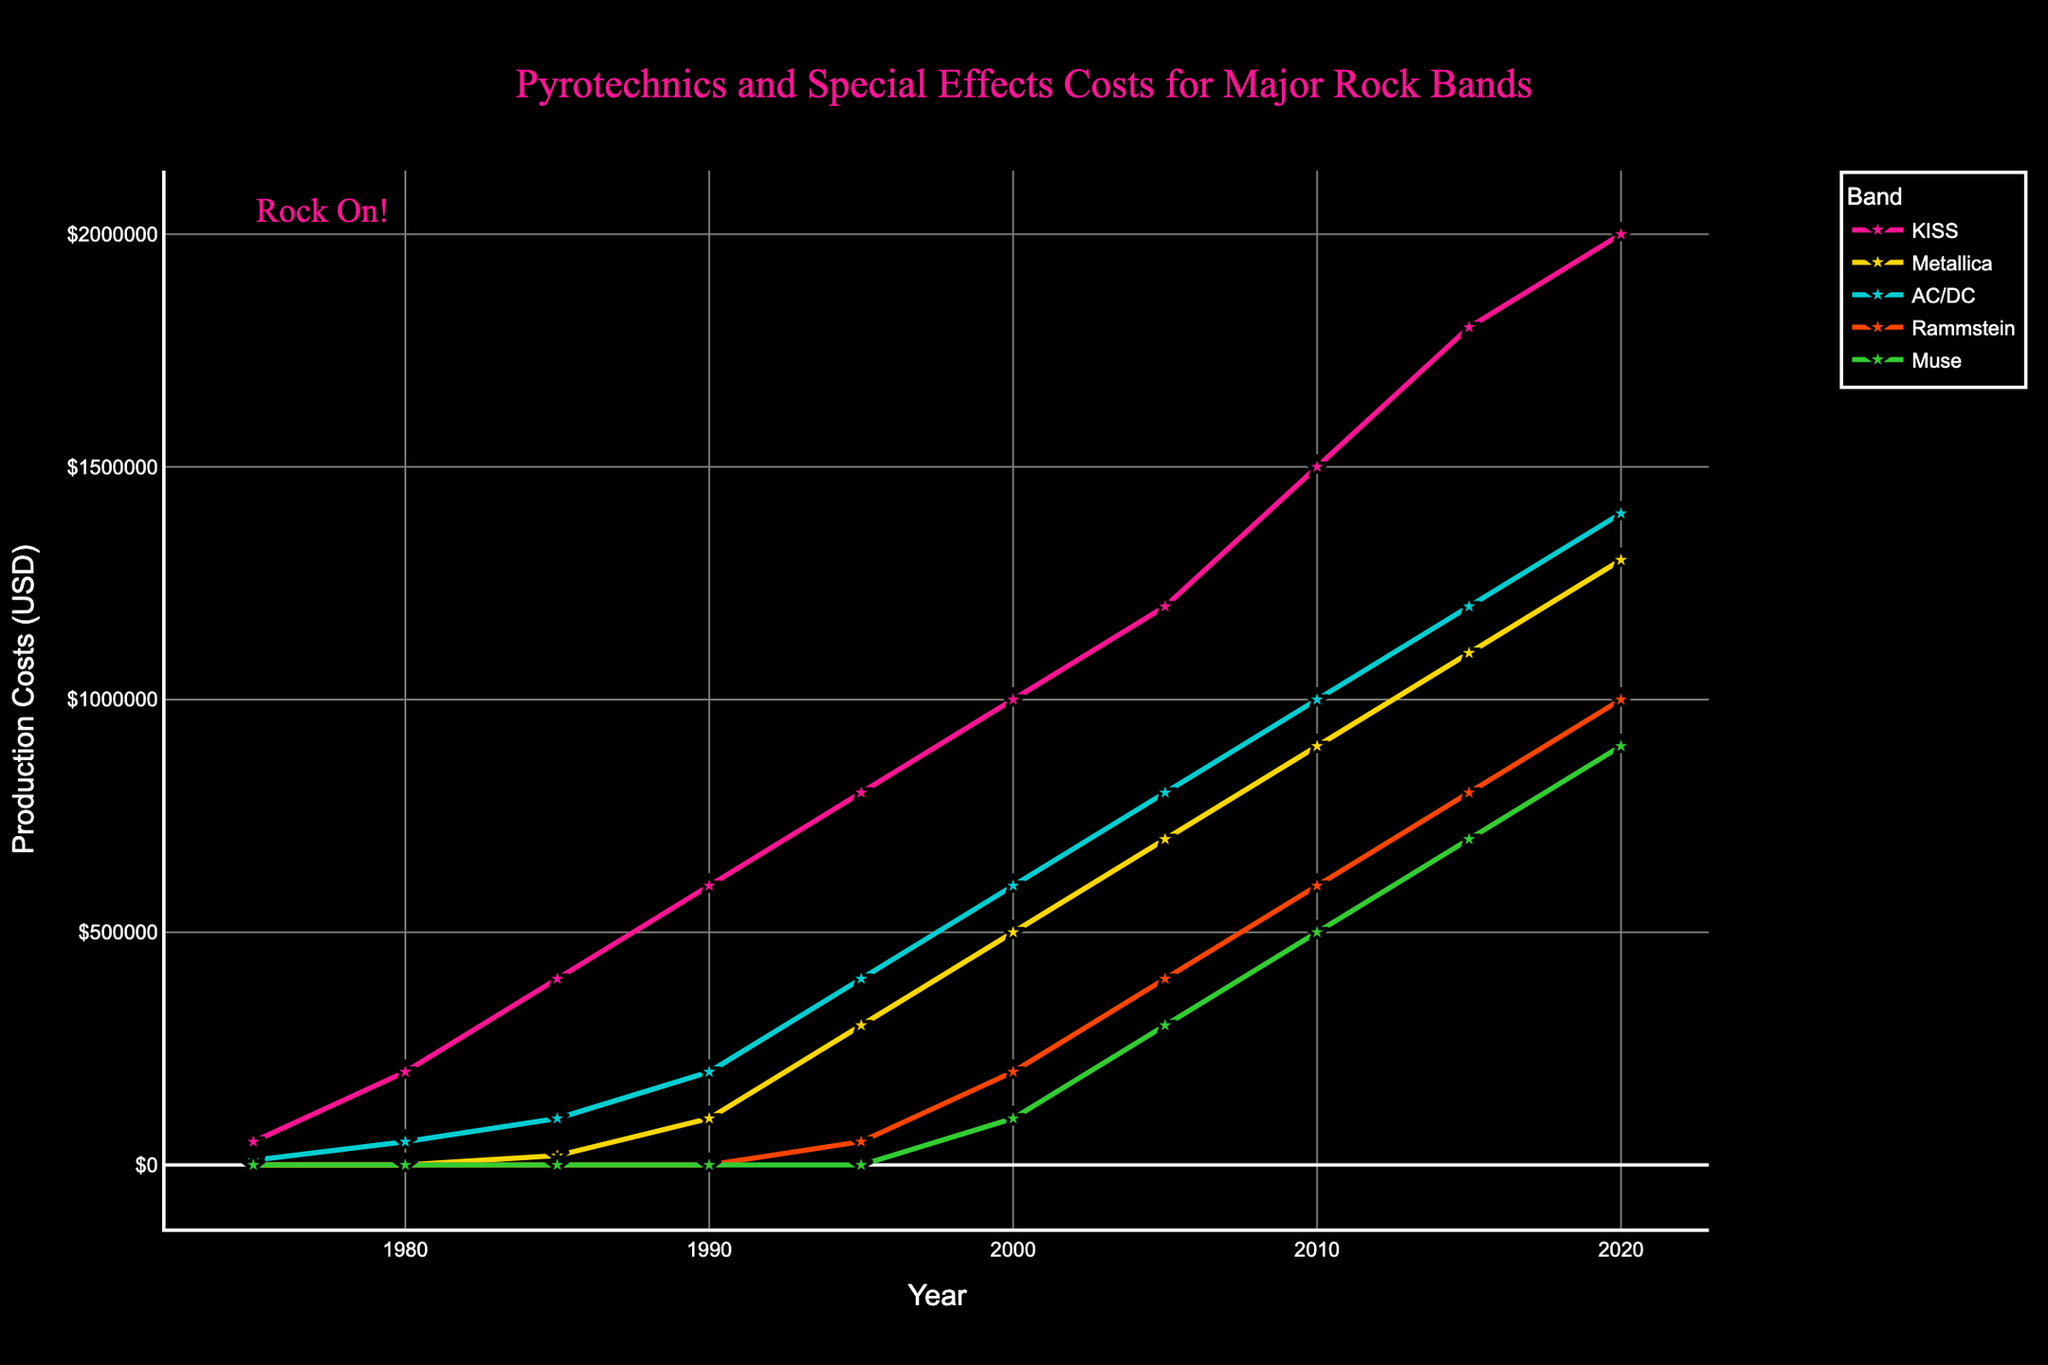Which band had the highest production costs in 2020? The chart shows the production costs in 2020 for each band. KISS had the highest bar, indicating the highest production costs.
Answer: KISS How did Muse's production costs change from 2000 to 2010? Muse's production costs increased from a small value in 2000 to a higher value in 2010, as observed from the rising line.
Answer: Increased Which band saw the largest increase in production costs between 1985 and 1990? By comparing the values at 1985 and 1990 for each band, KISS's production costs increased the most from 400,000 to 600,000.
Answer: KISS What is the average production cost for AC/DC over the 10 years provided? The values for AC/DC are 10,000, 50,000, 100,000, 200,000, 400,000, 600,000, 800,000, 1,000,000, 1,200,000, and 1,400,000. Adding these and dividing by 10 gives the average: (10,000+50,000+100,000+200,000+400,000+600,000+800,000+1,000,000+1,200,000+1,400,000) / 10.
Answer: 576,000 Compare KISS and Rammstein in 2015. Who had the higher production costs and by how much? KISS had 1,800,000, and Rammstein had 800,000 in 2015. So, subtract Rammstein's costs from KISS's costs to find the difference.
Answer: KISS by 1,000,000 Which years did Metallica start and significantly increase their production costs? Metallica started showing production costs in 1985 and had significant increases by looking at the steep rises between the years. They started in 1985 and had significant increases especially in 1995 and 2015.
Answer: 1985, 1995, and 2015 Did any band's production costs decrease between any two consecutive years? If yes, identify the band and years. By observing the lines, all production costs either increased or remained the same for each band through the years shown.
Answer: No In what year did Rammstein start investing in production costs for pyrotechnics and special effects? The chart shows Rammstein's first production cost in 1995.
Answer: 1995 